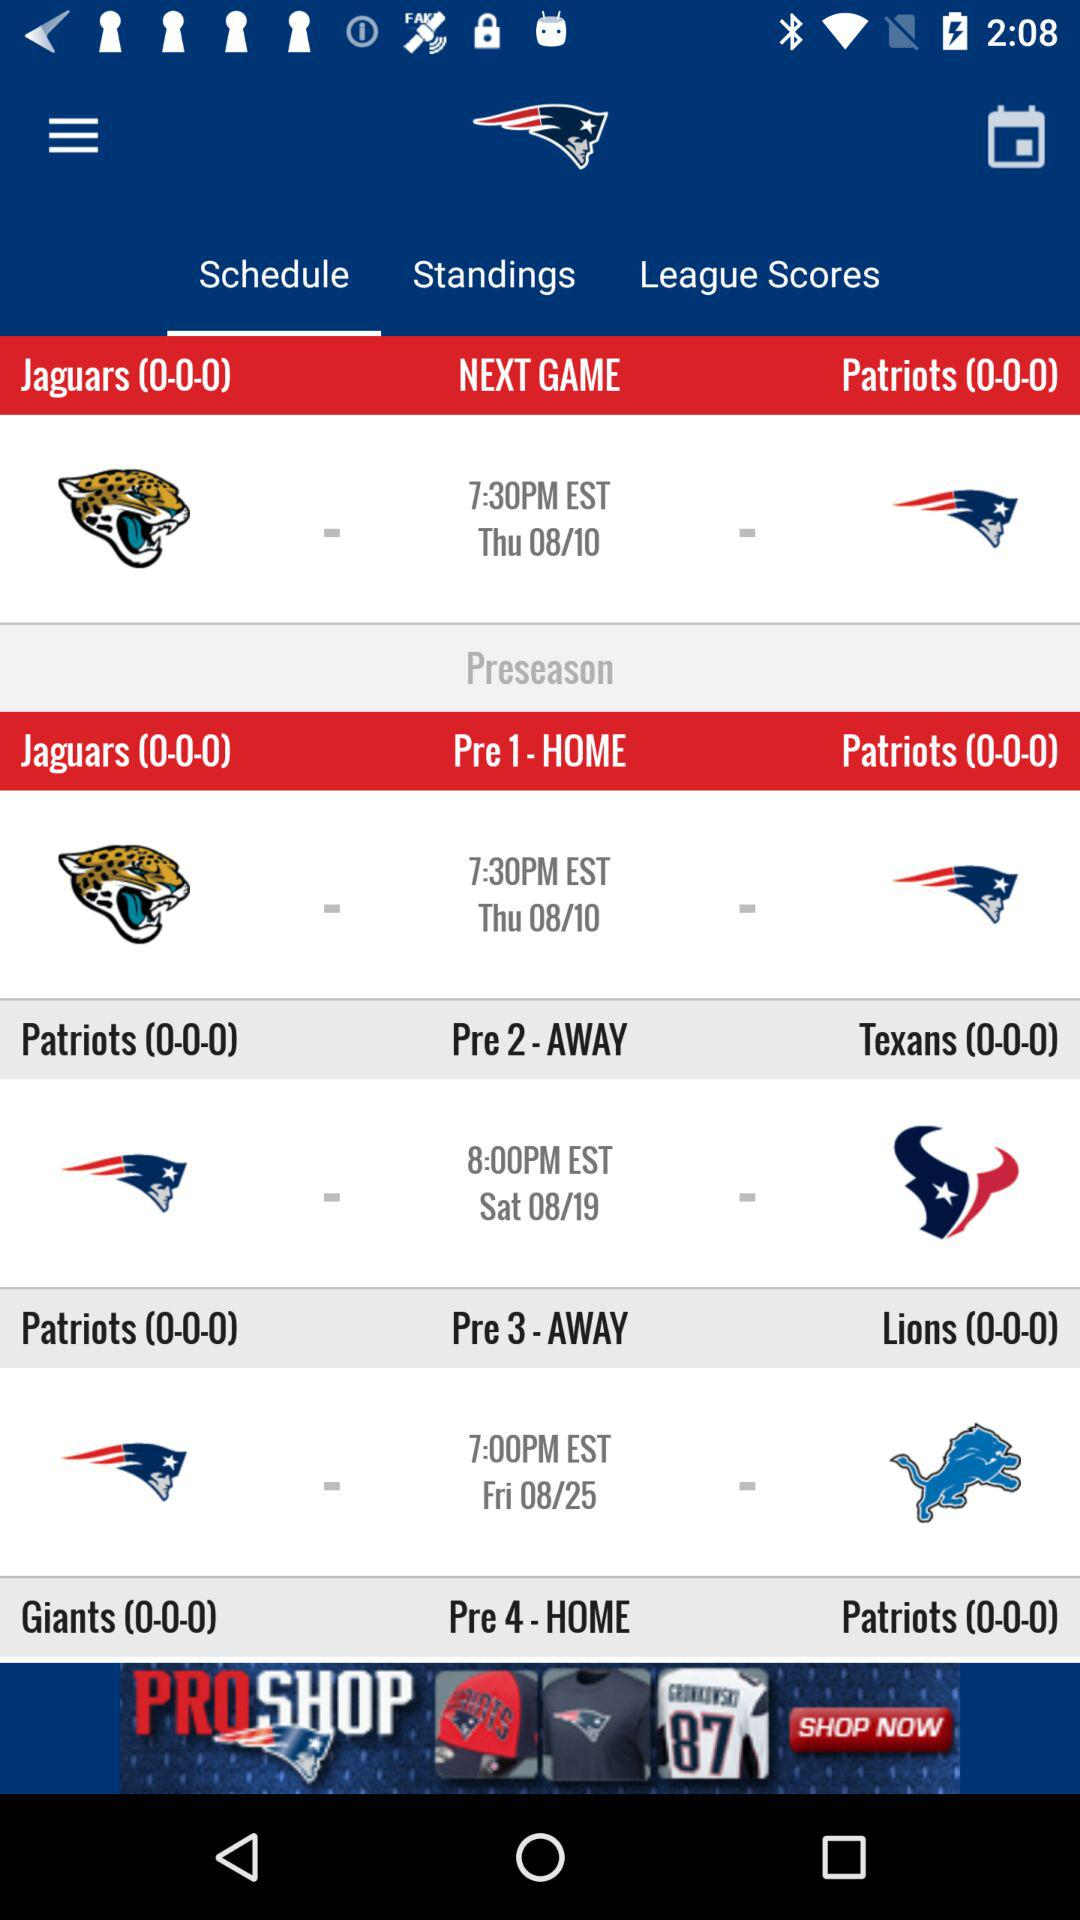How many games are scheduled for the preseason?
Answer the question using a single word or phrase. 4 